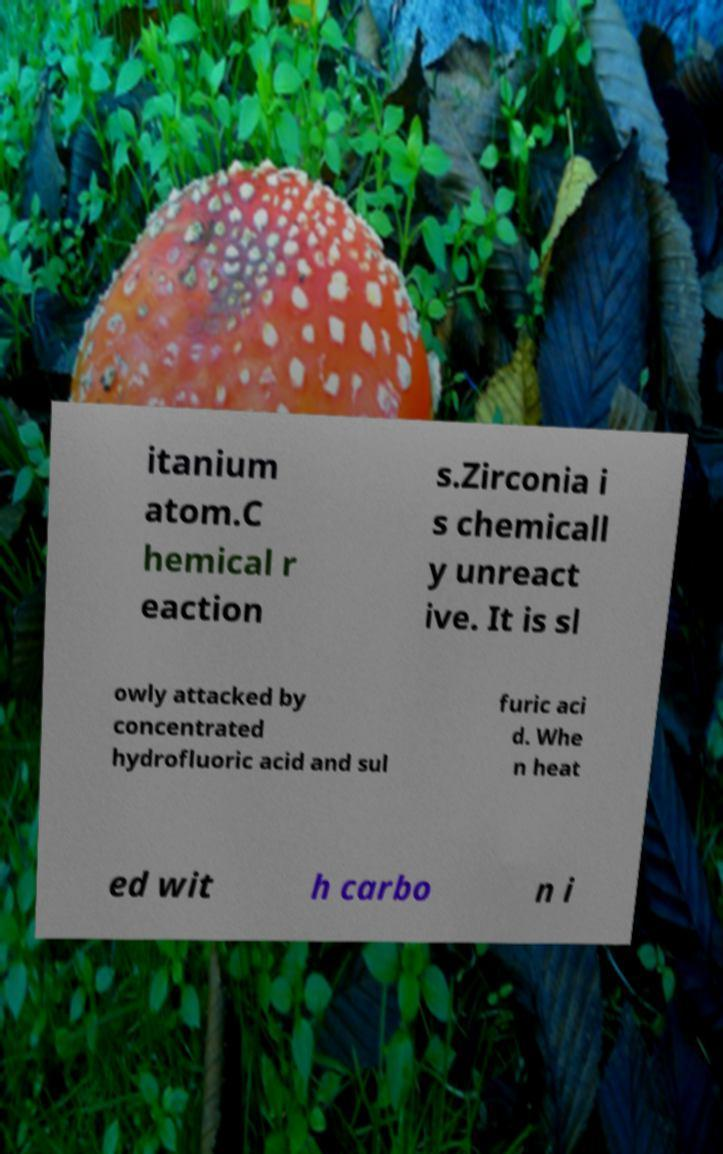Could you assist in decoding the text presented in this image and type it out clearly? itanium atom.C hemical r eaction s.Zirconia i s chemicall y unreact ive. It is sl owly attacked by concentrated hydrofluoric acid and sul furic aci d. Whe n heat ed wit h carbo n i 